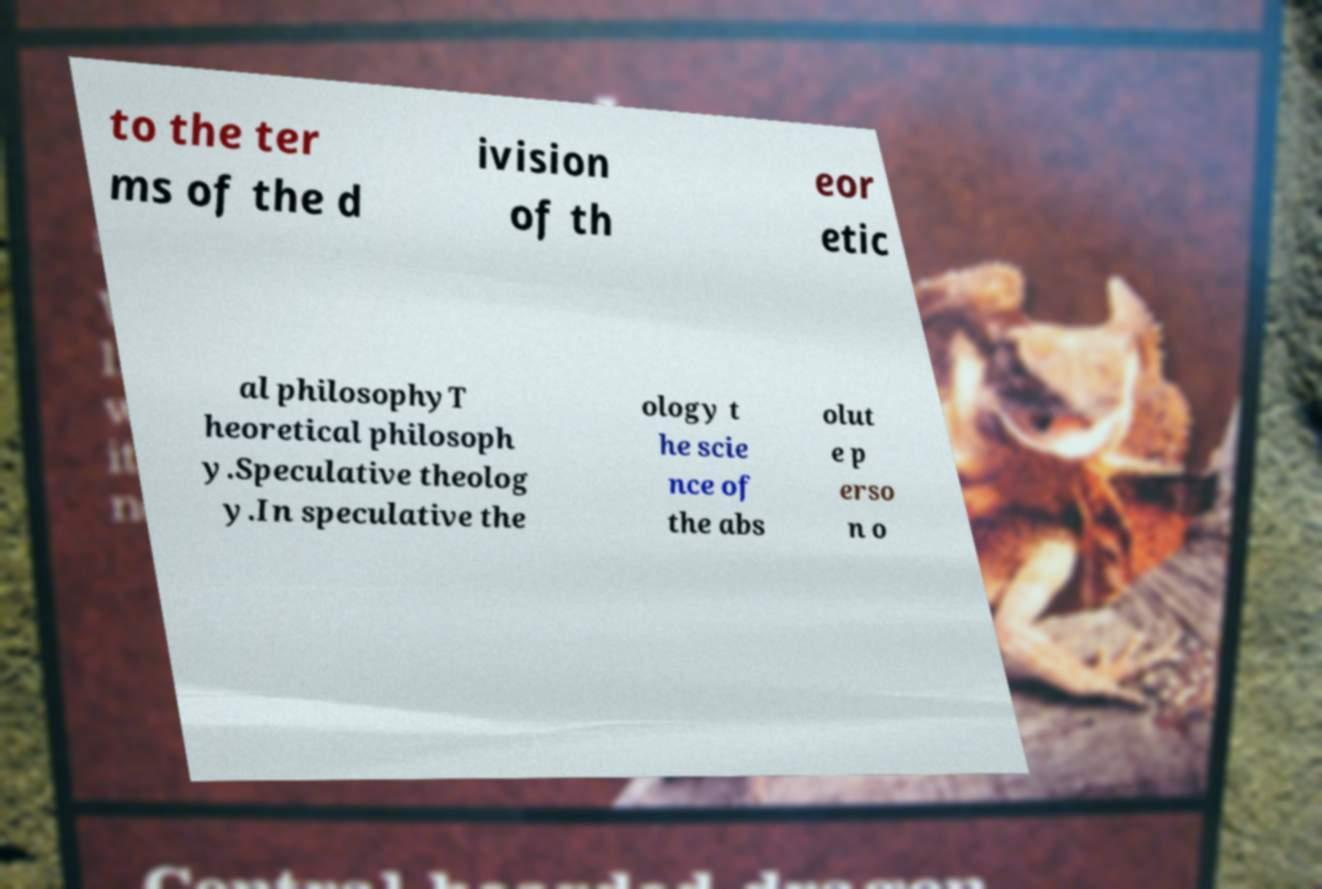I need the written content from this picture converted into text. Can you do that? to the ter ms of the d ivision of th eor etic al philosophyT heoretical philosoph y.Speculative theolog y.In speculative the ology t he scie nce of the abs olut e p erso n o 